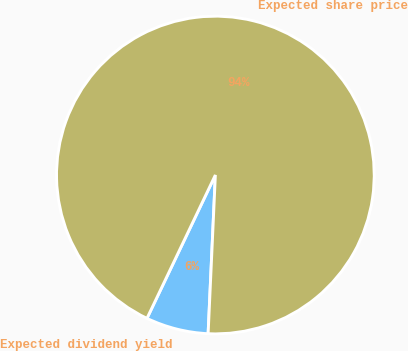Convert chart. <chart><loc_0><loc_0><loc_500><loc_500><pie_chart><fcel>Expected dividend yield<fcel>Expected share price<nl><fcel>6.36%<fcel>93.64%<nl></chart> 